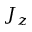Convert formula to latex. <formula><loc_0><loc_0><loc_500><loc_500>J _ { z }</formula> 